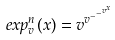Convert formula to latex. <formula><loc_0><loc_0><loc_500><loc_500>e x p _ { v } ^ { n } ( x ) = v ^ { v ^ { - ^ { - ^ { v ^ { x } } } } }</formula> 